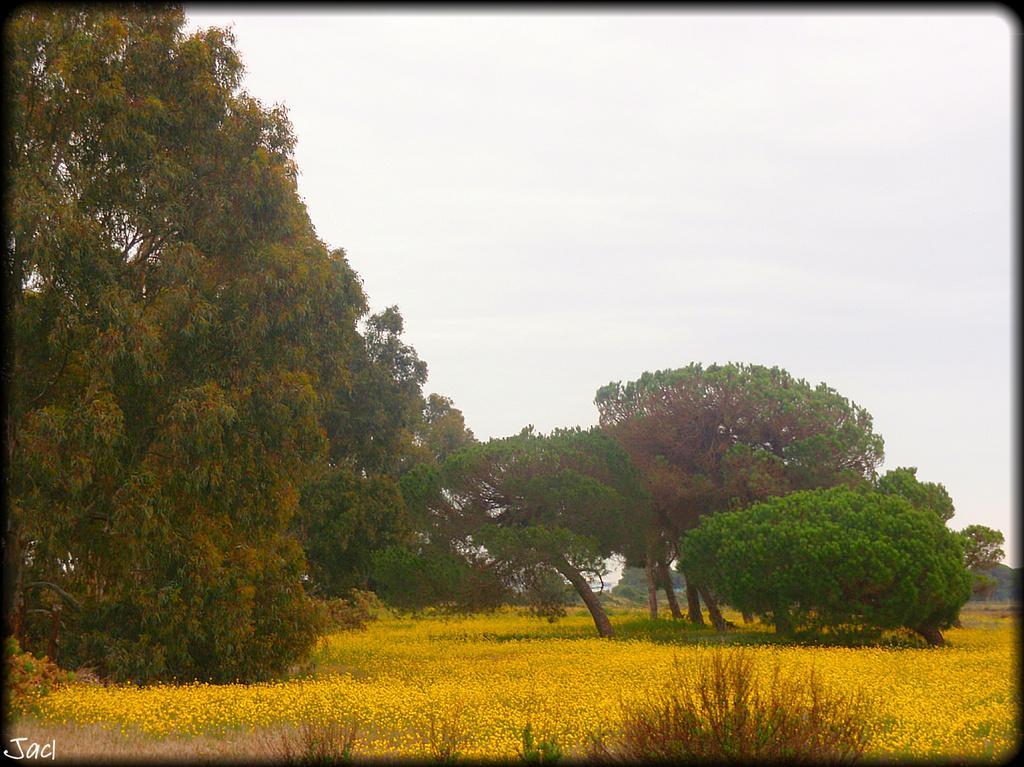How would you summarize this image in a sentence or two? In this picture, there are trees. At the bottom, there are flowers which are in yellow in color. On the top, there is a sky. 